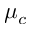<formula> <loc_0><loc_0><loc_500><loc_500>\mu _ { c }</formula> 